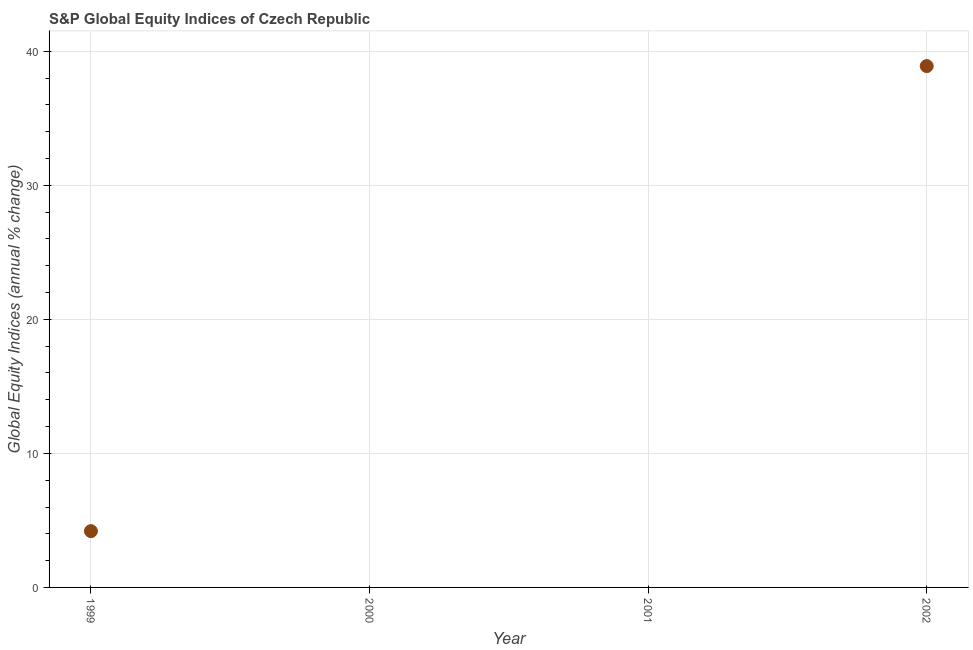What is the s&p global equity indices in 2001?
Provide a succinct answer. 0. Across all years, what is the maximum s&p global equity indices?
Ensure brevity in your answer.  38.9. Across all years, what is the minimum s&p global equity indices?
Offer a very short reply. 0. What is the sum of the s&p global equity indices?
Keep it short and to the point. 43.1. What is the difference between the s&p global equity indices in 1999 and 2002?
Make the answer very short. -34.7. What is the average s&p global equity indices per year?
Offer a very short reply. 10.78. What is the median s&p global equity indices?
Make the answer very short. 2.1. What is the ratio of the s&p global equity indices in 1999 to that in 2002?
Give a very brief answer. 0.11. Is the s&p global equity indices in 1999 less than that in 2002?
Your response must be concise. Yes. What is the difference between the highest and the lowest s&p global equity indices?
Ensure brevity in your answer.  38.9. Does the s&p global equity indices monotonically increase over the years?
Keep it short and to the point. No. How many years are there in the graph?
Give a very brief answer. 4. What is the difference between two consecutive major ticks on the Y-axis?
Provide a short and direct response. 10. Are the values on the major ticks of Y-axis written in scientific E-notation?
Give a very brief answer. No. Does the graph contain any zero values?
Provide a succinct answer. Yes. Does the graph contain grids?
Offer a terse response. Yes. What is the title of the graph?
Your response must be concise. S&P Global Equity Indices of Czech Republic. What is the label or title of the X-axis?
Give a very brief answer. Year. What is the label or title of the Y-axis?
Provide a succinct answer. Global Equity Indices (annual % change). What is the Global Equity Indices (annual % change) in 1999?
Your response must be concise. 4.2. What is the Global Equity Indices (annual % change) in 2000?
Provide a short and direct response. 0. What is the Global Equity Indices (annual % change) in 2001?
Your answer should be compact. 0. What is the Global Equity Indices (annual % change) in 2002?
Keep it short and to the point. 38.9. What is the difference between the Global Equity Indices (annual % change) in 1999 and 2002?
Offer a very short reply. -34.7. What is the ratio of the Global Equity Indices (annual % change) in 1999 to that in 2002?
Your answer should be compact. 0.11. 